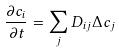Convert formula to latex. <formula><loc_0><loc_0><loc_500><loc_500>\frac { \partial c _ { i } } { \partial t } = \sum _ { j } D _ { i j } \Delta c _ { j }</formula> 